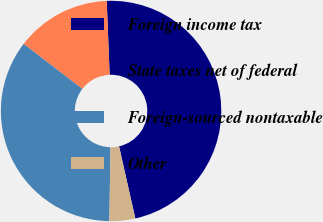<chart> <loc_0><loc_0><loc_500><loc_500><pie_chart><fcel>Foreign income tax<fcel>State taxes net of federal<fcel>Foreign-sourced nontaxable<fcel>Other<nl><fcel>47.1%<fcel>13.95%<fcel>35.18%<fcel>3.78%<nl></chart> 